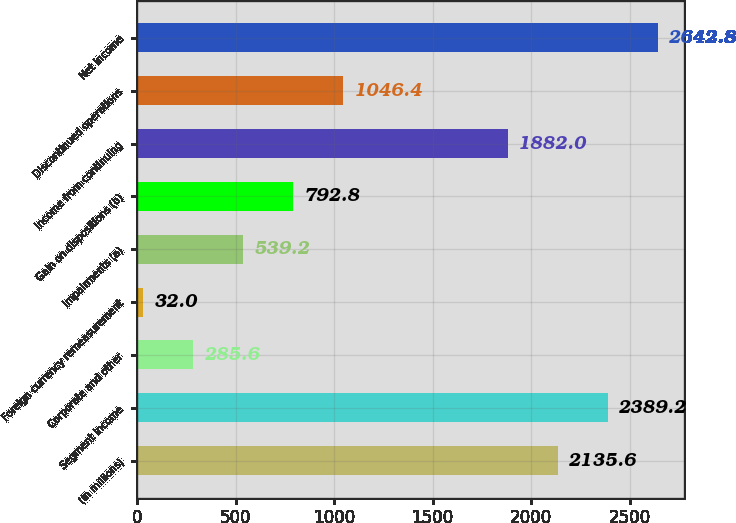Convert chart. <chart><loc_0><loc_0><loc_500><loc_500><bar_chart><fcel>(In millions)<fcel>Segment income<fcel>Corporate and other<fcel>Foreign currency remeasurement<fcel>Impairments (a)<fcel>Gain on dispositions (b)<fcel>Income from continuing<fcel>Discontinued operations<fcel>Net income<nl><fcel>2135.6<fcel>2389.2<fcel>285.6<fcel>32<fcel>539.2<fcel>792.8<fcel>1882<fcel>1046.4<fcel>2642.8<nl></chart> 